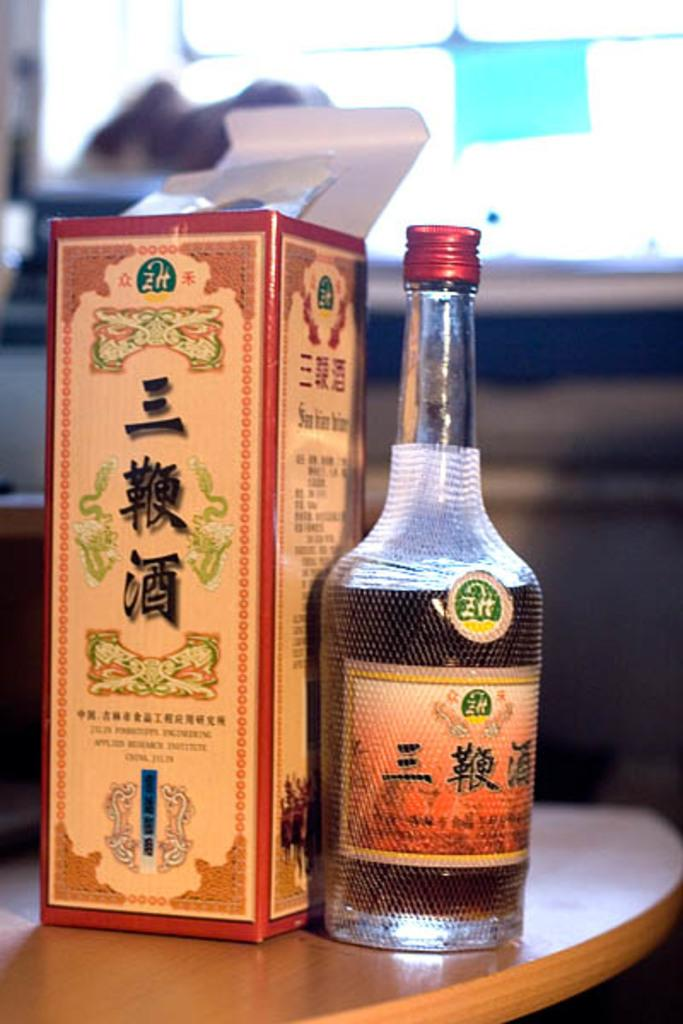<image>
Write a terse but informative summary of the picture. Bottle of asian alcohol next to a box with some foreign writing. 